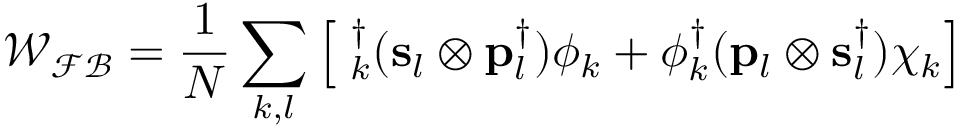<formula> <loc_0><loc_0><loc_500><loc_500>{ \mathcal { W _ { F B } } } = \frac { 1 } { N } \sum _ { k , l } \left [ { \chi } _ { k } ^ { \dag } ( { s } _ { l } \otimes { p } _ { l } ^ { \dag } ) \phi _ { k } + \phi _ { k } ^ { \dag } ( { p } _ { l } \otimes { s } _ { l } ^ { \dag } ) \chi _ { k } \right ]</formula> 